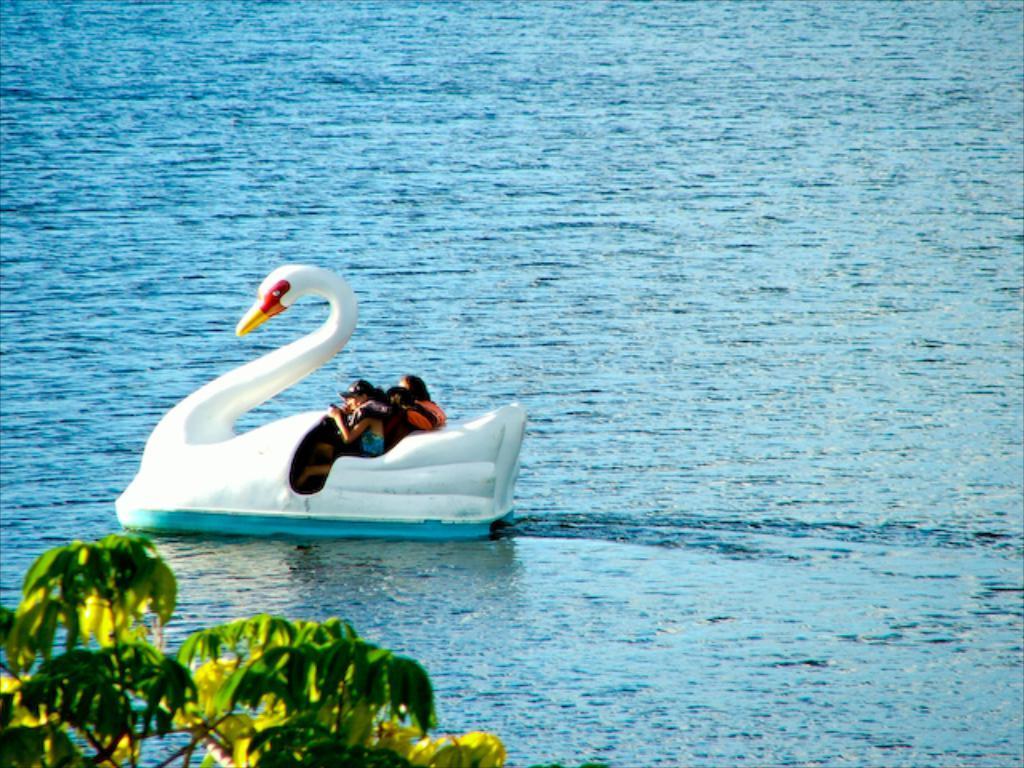Please provide a concise description of this image. In this picture there is a boat in the shape of a duck on the water and there are people those who are sitting on it and there is a tree at the bottom side of the image. 